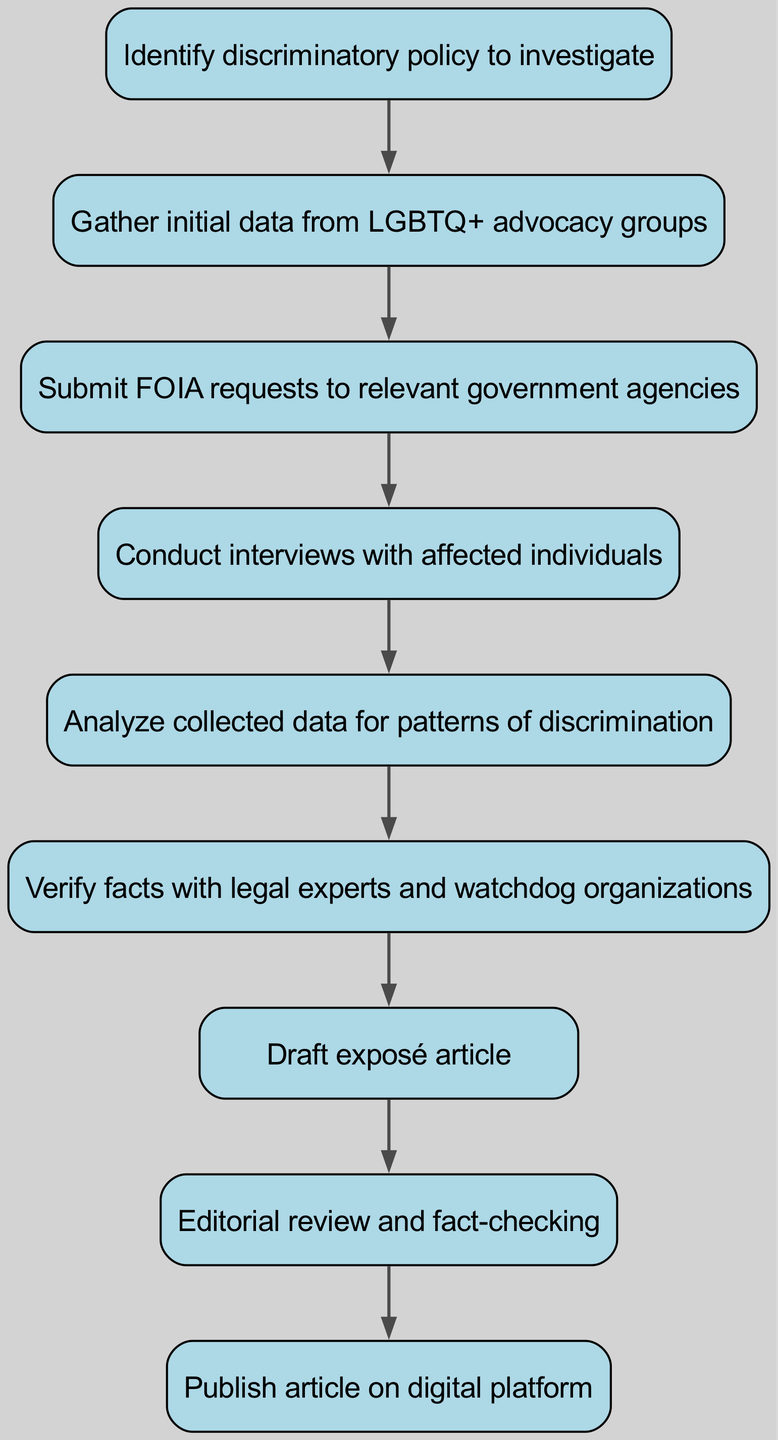What is the first step in the workflow? The first node in the flowchart indicates "Identify discriminatory policy to investigate," which is the initial action in the workflow.
Answer: Identify discriminatory policy to investigate How many nodes are present in the diagram? By counting the individual steps outlined in the diagram, there are a total of eight nodes in the workflow.
Answer: 8 What follows the submission of FOIA requests? The edge originating from the "Submit FOIA requests to relevant government agencies" node leads to the "Conduct interviews with affected individuals" node. This means that interviews are the next step after submitting FOIA requests.
Answer: Conduct interviews with affected individuals Which node is directly connected to the "Analyze collected data for patterns of discrimination"? The edge from the "Analyze collected data for patterns of discrimination" connects to the "Verify facts with legal experts and watchdog organizations" node, indicating that verification follows analysis.
Answer: Verify facts with legal experts and watchdog organizations After the editorial review, what is the final step in this workflow? The last node connected after the "Editorial review and fact-checking" is "Publish article on digital platform," which indicates the conclusion of the workflow.
Answer: Publish article on digital platform How many edges connect the nodes in the workflow? By examining the arrows that signify connections between the nodes, there are a total of seven edges that establish the flow of the process.
Answer: 7 Describe the path from gathering data to publishing the article. The path begins at "Gather initial data from LGBTQ+ advocacy groups," followed by "Submit FOIA requests to relevant government agencies," then "Conduct interviews with affected individuals," followed by "Analyze collected data for patterns of discrimination," next is "Verify facts with legal experts and watchdog organizations," then "Draft exposé article," followed by "Editorial review and fact-checking," and finally "Publish article on digital platform." This sequence illustrates the complete workflow leading to publication.
Answer: Gather initial data from LGBTQ+ advocacy groups → Submit FOIA requests to relevant government agencies → Conduct interviews with affected individuals → Analyze collected data for patterns of discrimination → Verify facts with legal experts and watchdog organizations → Draft exposé article → Editorial review and fact-checking → Publish article on digital platform 